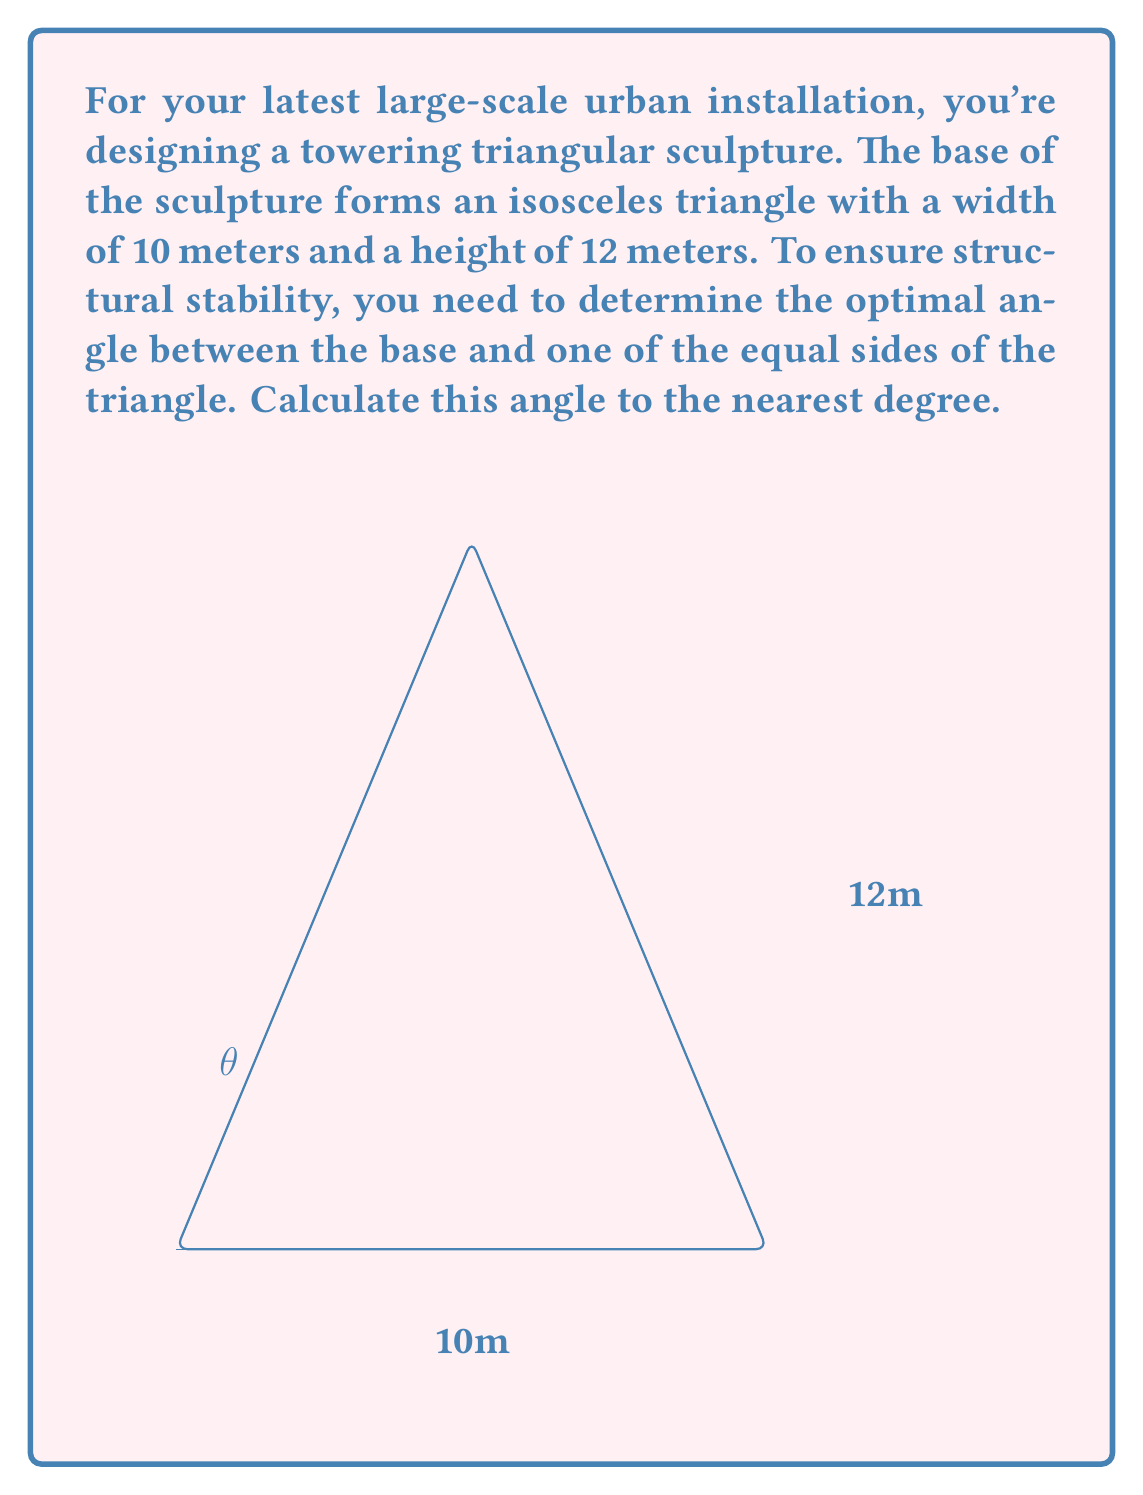Could you help me with this problem? To solve this problem, we'll use trigonometry within the right triangle formed by bisecting the isosceles triangle:

1) First, we identify the known dimensions:
   - Base width = 10 meters
   - Height = 12 meters

2) We need to find the angle $\theta$ between the base and one of the equal sides.

3) In the right triangle formed by the bisector:
   - The base is half of the total width: $\frac{10}{2} = 5$ meters
   - The height remains 12 meters

4) We can use the arctangent function to find the angle:

   $$\theta = \arctan(\frac{\text{opposite}}{\text{adjacent}}) = \arctan(\frac{12}{5})$$

5) Calculate:
   $$\theta = \arctan(2.4) \approx 67.38^\circ$$

6) Rounding to the nearest degree:
   $$\theta \approx 67^\circ$$

This angle provides the optimal balance between height and base width for structural stability in this large-scale installation.
Answer: The optimal angle for structural stability is approximately $67^\circ$. 